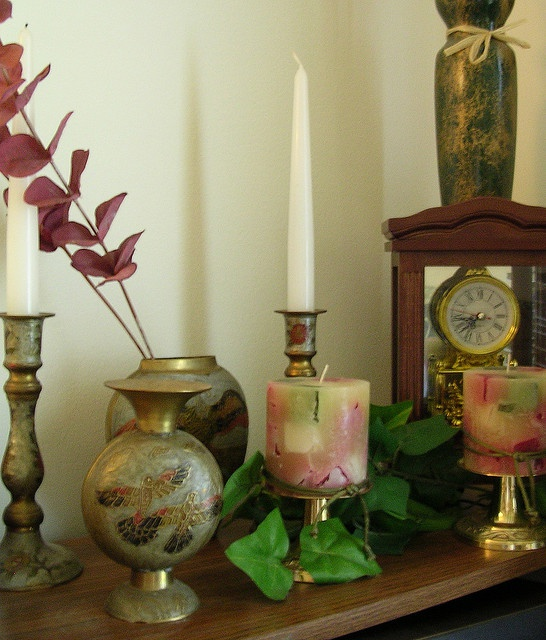Describe the objects in this image and their specific colors. I can see vase in brown, olive, black, and maroon tones, vase in brown, olive, black, and tan tones, vase in brown, black, and olive tones, and clock in brown, olive, and gray tones in this image. 